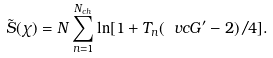Convert formula to latex. <formula><loc_0><loc_0><loc_500><loc_500>\tilde { S } ( \chi ) = N \sum _ { n = 1 } ^ { N _ { c h } } \ln [ 1 + T _ { n } ( \ v c G ^ { \prime } - 2 ) / 4 ] .</formula> 